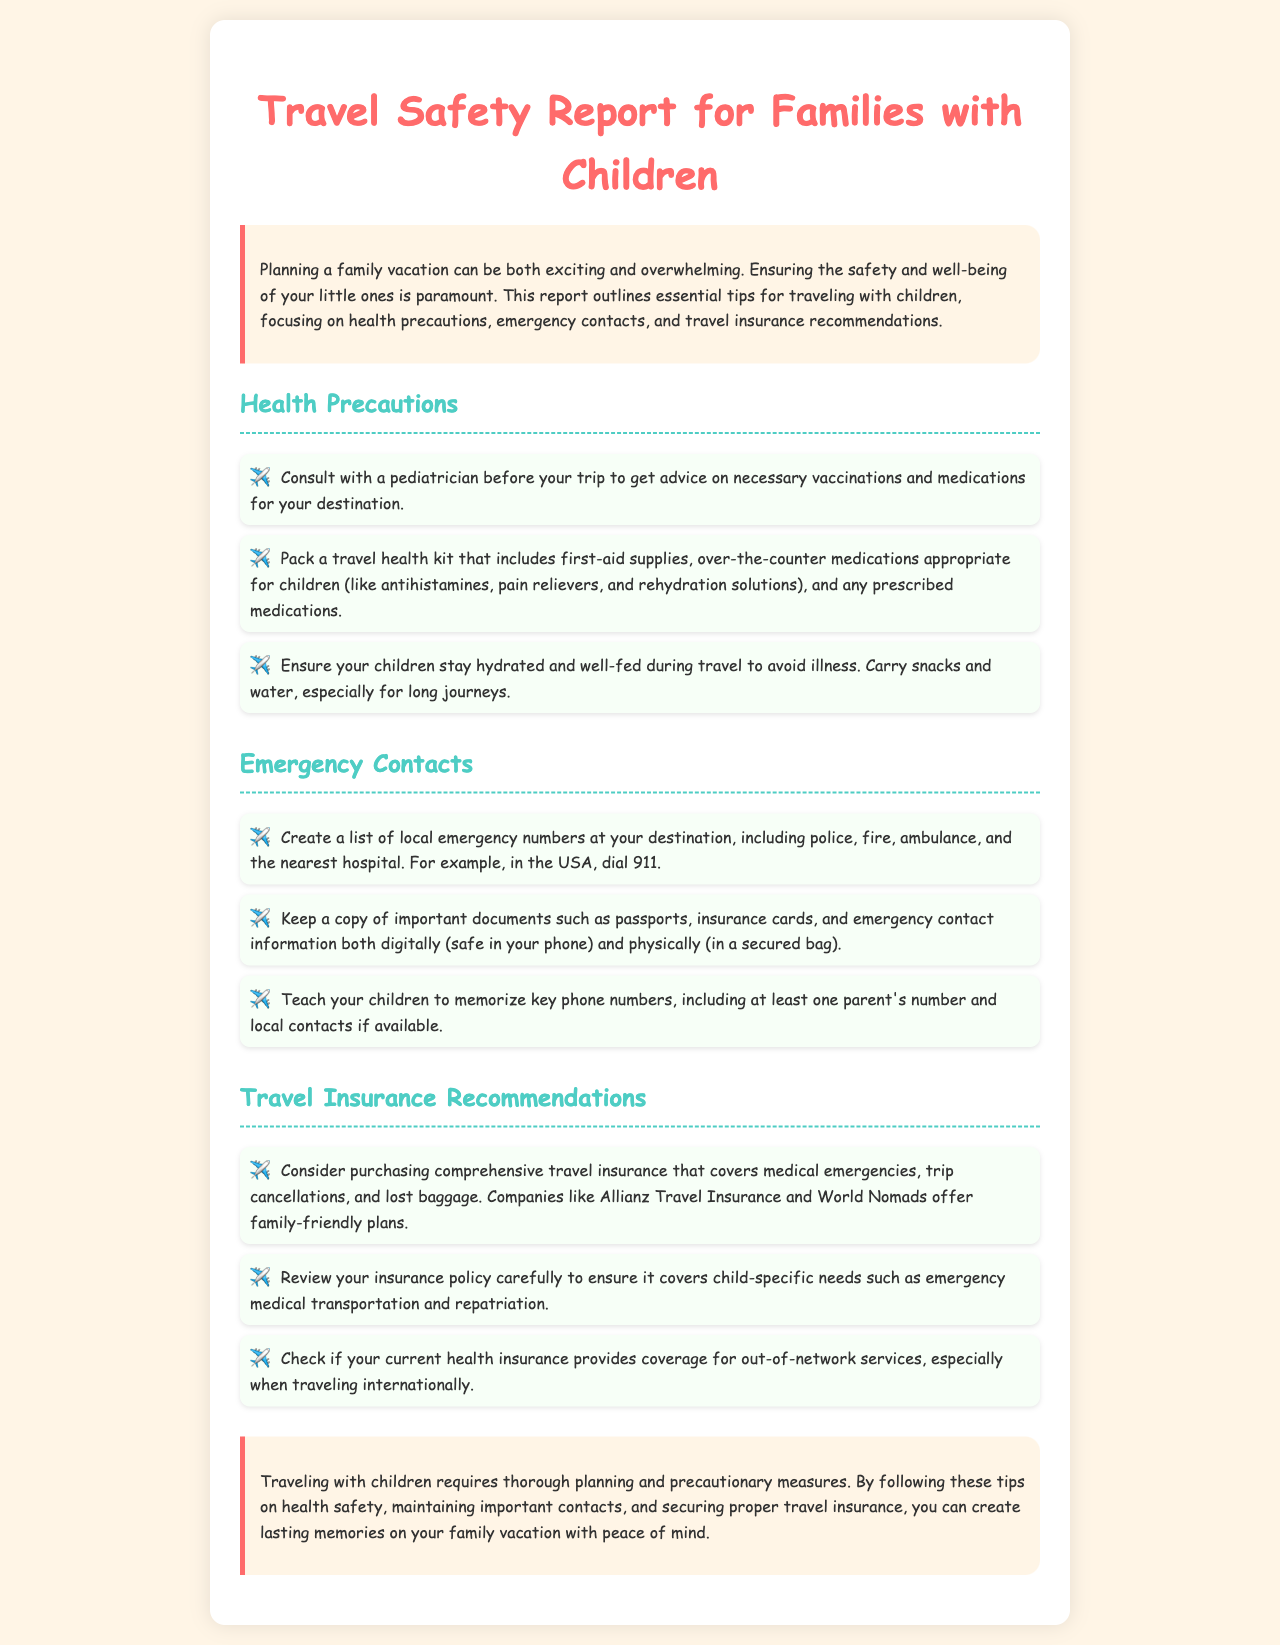What should you consult with before your trip? The document advises consulting with a pediatrician for advice on necessary vaccinations and medications.
Answer: Pediatrician What should you pack in your travel health kit? The report specifically mentions packing first-aid supplies, over-the-counter medications, and prescribed medications.
Answer: First-aid supplies, over-the-counter medications, prescribed medications What number should you call for emergencies in the USA? The document states that in the USA, one should dial 911 for emergencies.
Answer: 911 Which travel insurance companies are mentioned? The report lists Allianz Travel Insurance and World Nomads as companies offering family-friendly plans.
Answer: Allianz Travel Insurance, World Nomads What type of meal should children have during travel? The document emphasizes that children should stay well-fed during travel to avoid illness.
Answer: Well-fed What important documents should be kept a copy of? The report suggests keeping a copy of passports, insurance cards, and emergency contact information.
Answer: Passports, insurance cards, emergency contact information What should children memorize according to the report? It is advised that children memorize key phone numbers including at least one parent's number.
Answer: Key phone numbers What does the report emphasize is essential for family vacations? The conclusion mentions thorough planning and precautionary measures as essential for family vacations.
Answer: Thorough planning and precautionary measures 